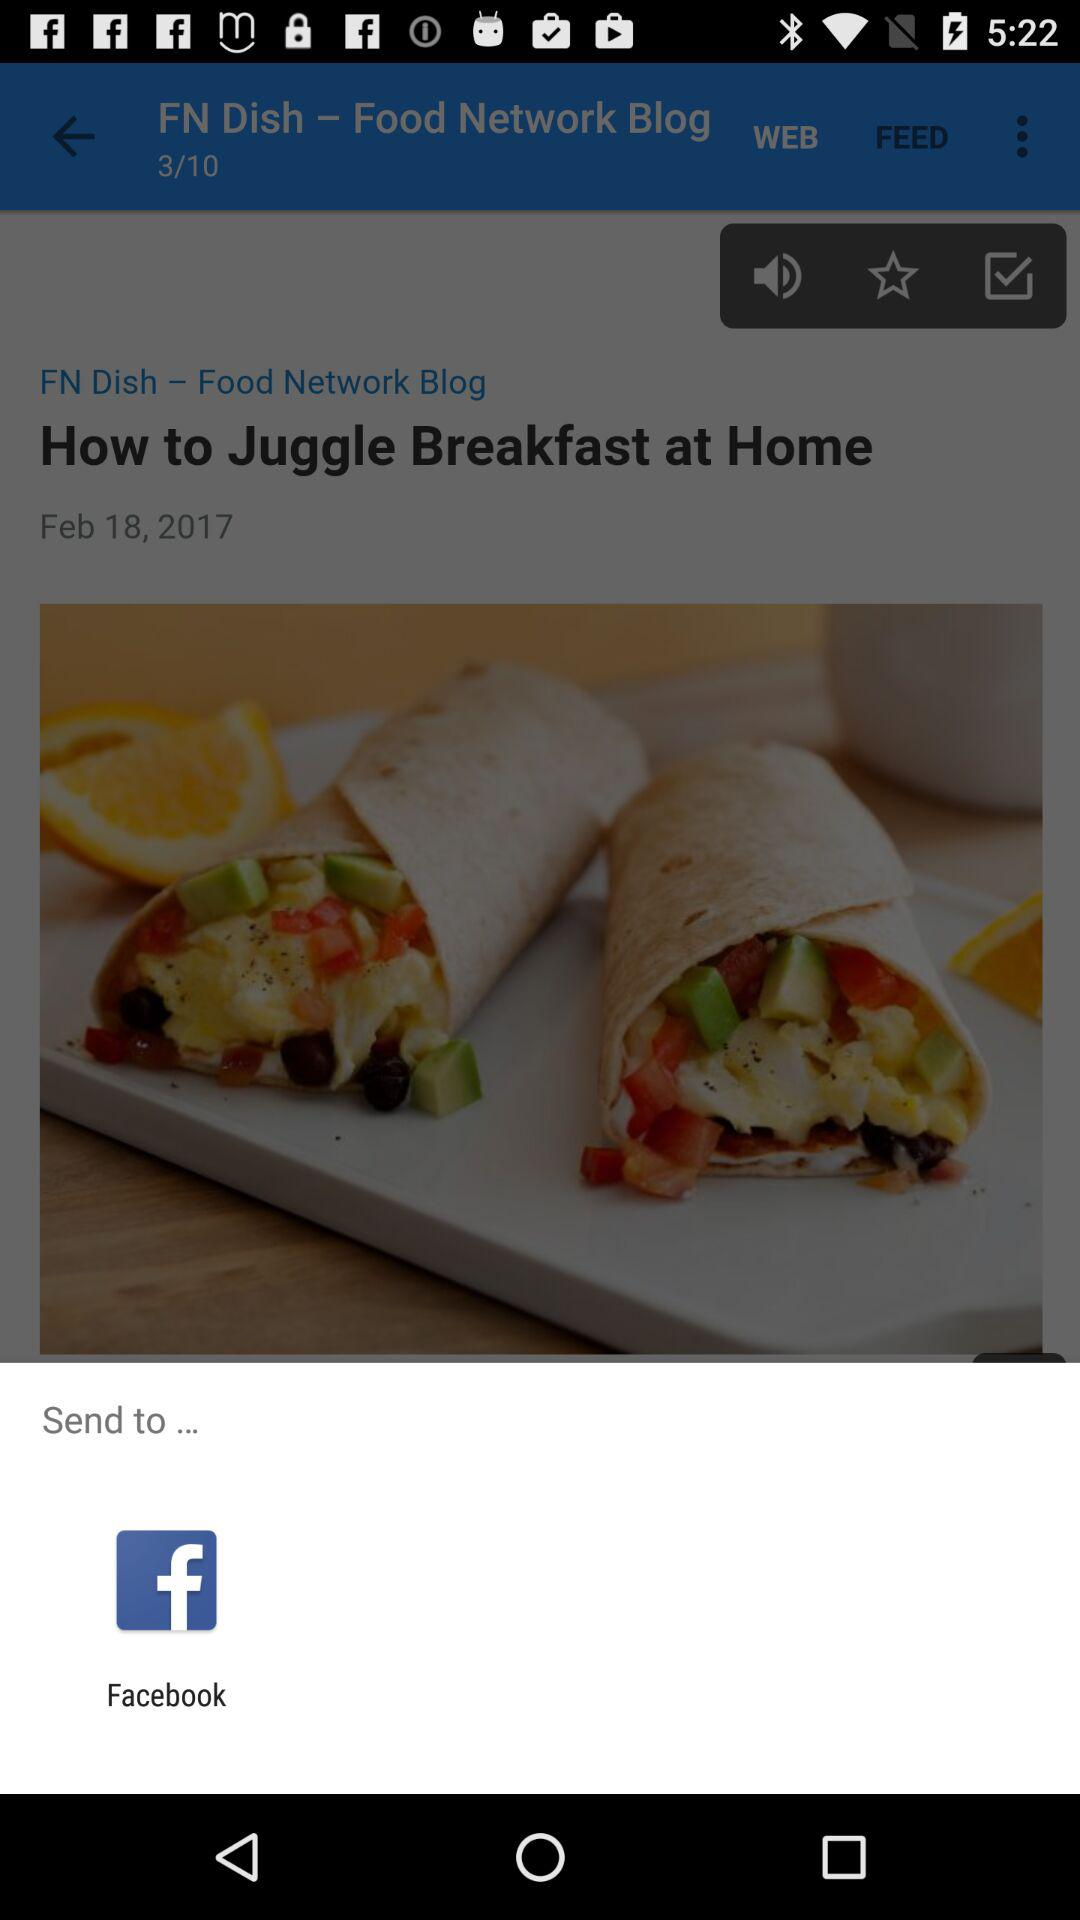Who posted the blog? The blog was posted by the "Food Network". 